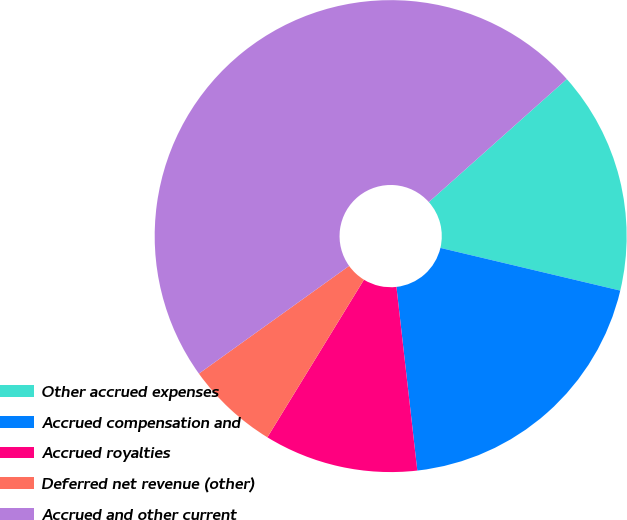Convert chart. <chart><loc_0><loc_0><loc_500><loc_500><pie_chart><fcel>Other accrued expenses<fcel>Accrued compensation and<fcel>Accrued royalties<fcel>Deferred net revenue (other)<fcel>Accrued and other current<nl><fcel>15.3%<fcel>19.49%<fcel>10.55%<fcel>6.35%<fcel>48.31%<nl></chart> 